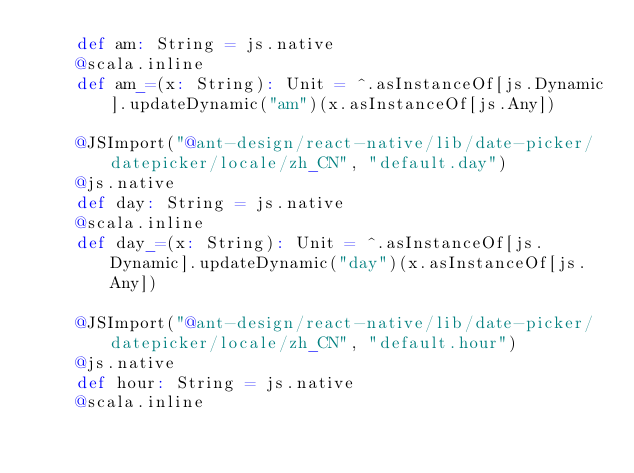Convert code to text. <code><loc_0><loc_0><loc_500><loc_500><_Scala_>    def am: String = js.native
    @scala.inline
    def am_=(x: String): Unit = ^.asInstanceOf[js.Dynamic].updateDynamic("am")(x.asInstanceOf[js.Any])
    
    @JSImport("@ant-design/react-native/lib/date-picker/datepicker/locale/zh_CN", "default.day")
    @js.native
    def day: String = js.native
    @scala.inline
    def day_=(x: String): Unit = ^.asInstanceOf[js.Dynamic].updateDynamic("day")(x.asInstanceOf[js.Any])
    
    @JSImport("@ant-design/react-native/lib/date-picker/datepicker/locale/zh_CN", "default.hour")
    @js.native
    def hour: String = js.native
    @scala.inline</code> 